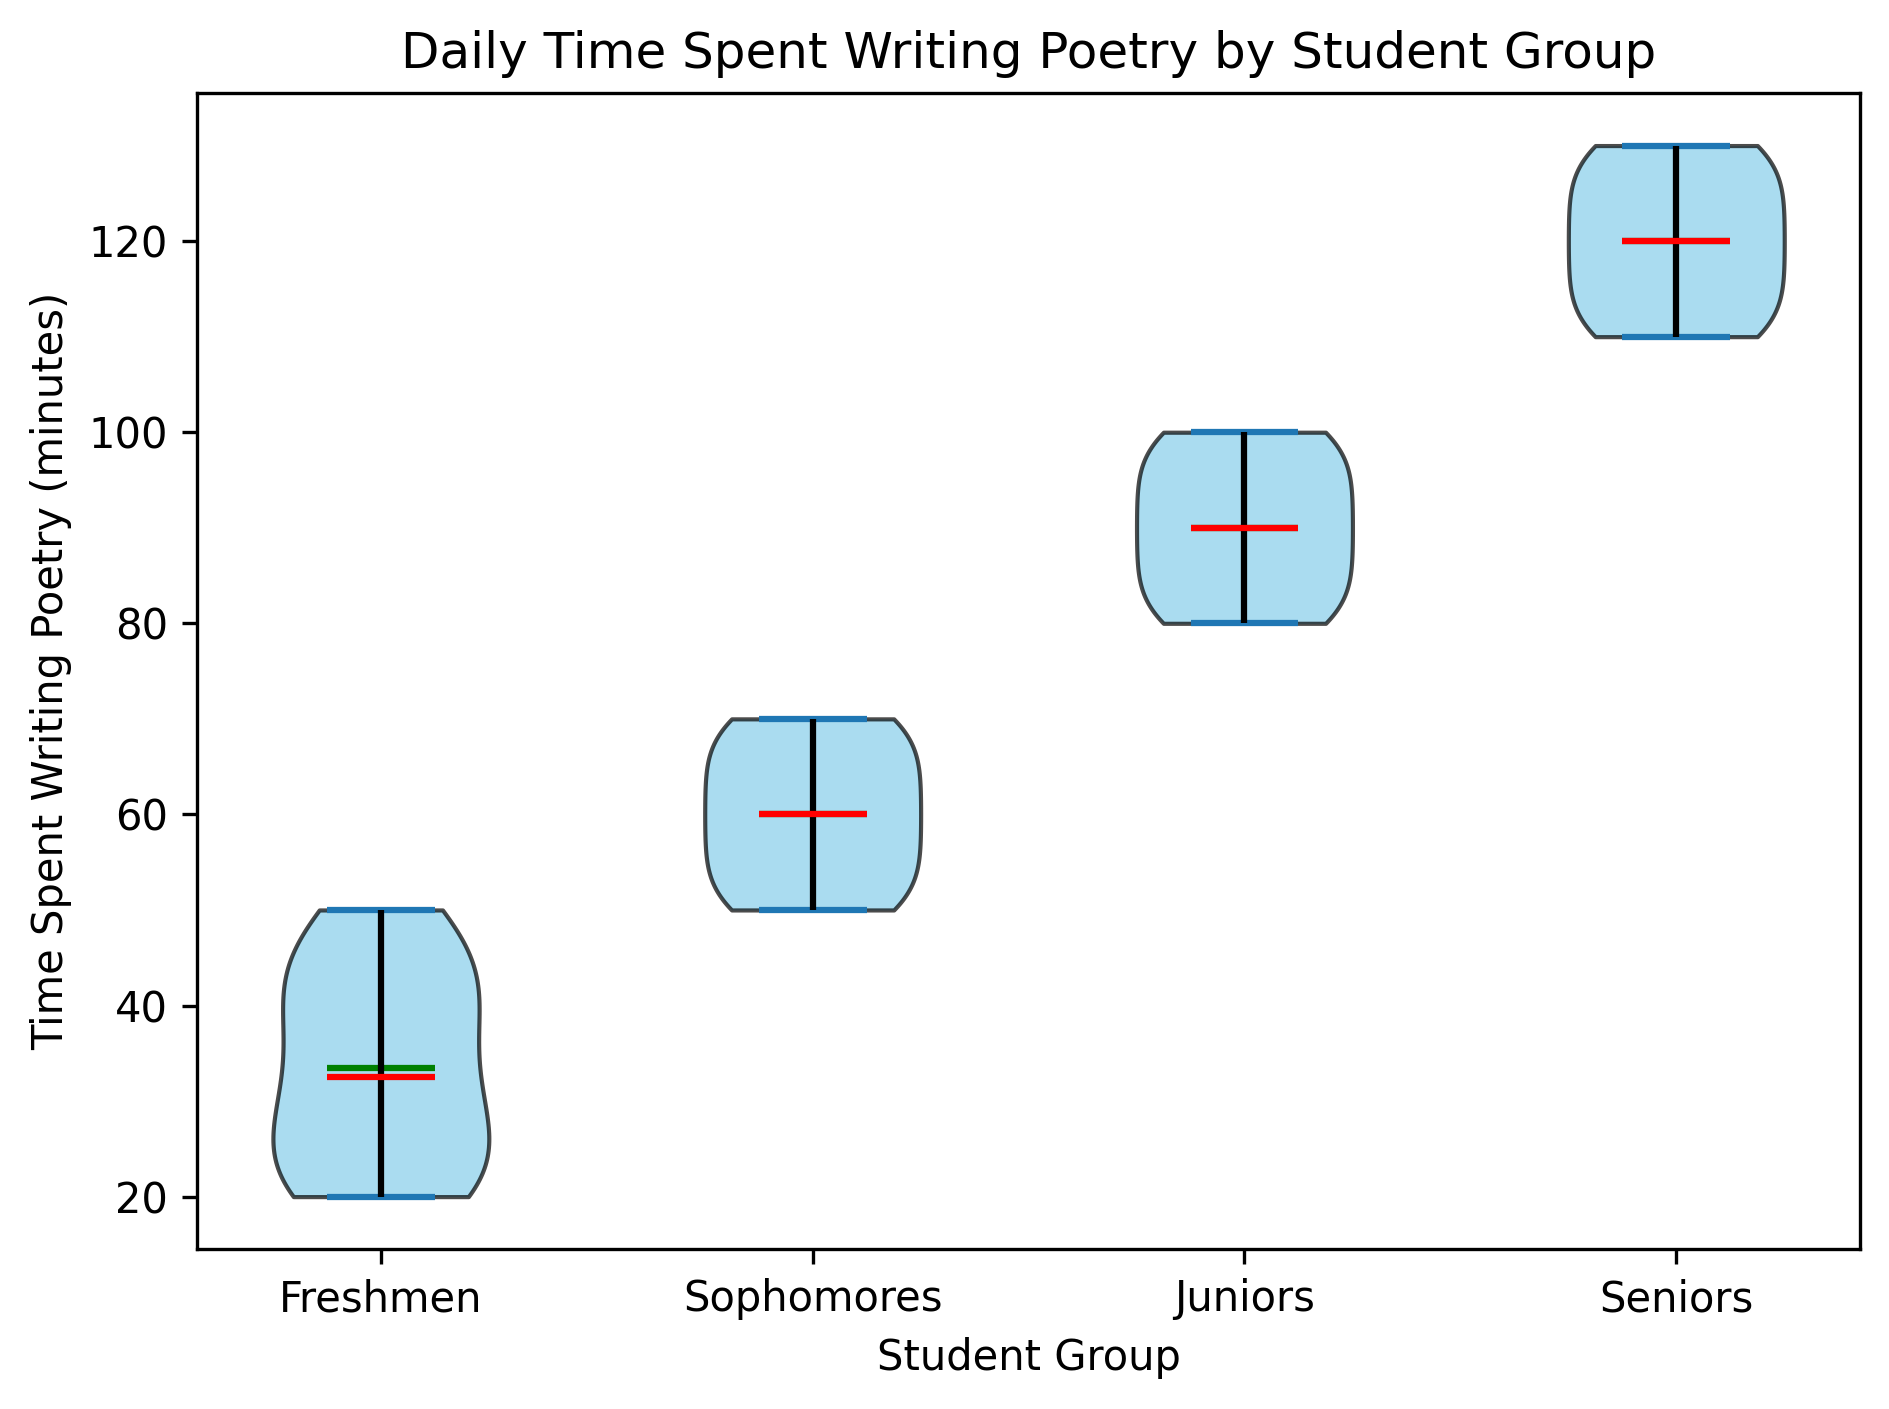Which student group spends the most time writing poetry on average? The figure displays the distribution of daily time spent writing poetry for each student group. The Seniors group shows the highest average time (indicated by the green line for the mean) compared to the Freshmen, Sophomores, and Juniors groups.
Answer: Seniors What is the median time spent writing poetry for Juniors? The red line inside the violin plot for the Juniors group represents the median. By locating this line, we observe it at the midpoint of the distribution. For the Juniors, this median line is at 90 minutes.
Answer: 90 minutes How does the median time spent writing poetry of Sophomores compare to that of Freshmen? The red median line for Sophomores is higher than that for Freshmen. Specifically, the median for Sophomores is around 60 minutes, while for Freshmen, it is around 30 minutes.
Answer: Sophomores have a higher median time than Freshmen Which group displays the widest range of time spent writing poetry? The range can be determined by the length of each violin plot. Seniors have the widest plot, indicating the largest range (from about 110 to 130 minutes), while Freshmen have a narrower plot.
Answer: Seniors Are the mean and median times for any group the same? By observing the green (mean) and red (median) lines, we can compare their positions within each group. For Sophomores, the mean and median lines appear almost identical, both situated at around 60 minutes.
Answer: Sophomores What is the difference between the maximum time spent writing poetry for Juniors and Freshmen? Visual inspection shows the top of the Juniors' distribution touches 100 minutes, while the Freshmen's maximum is around 50 minutes. The difference is 100 - 50 = 50 minutes.
Answer: 50 minutes Is there a group where the median time is higher than the mean time? By comparing median lines (red) with mean lines (green) in each group, no such group shows a median higher than the mean. In all groups, the median is either equal to or lower than the mean.
Answer: No Which group has the narrowest interquartile range (IQR) of time spent writing poetry? IQR can be visually estimated by the width of the tightest portion of the violin plot. The Freshmen group shows the narrowest spread with most data points concentrated around 30 to 40 minutes.
Answer: Freshmen 